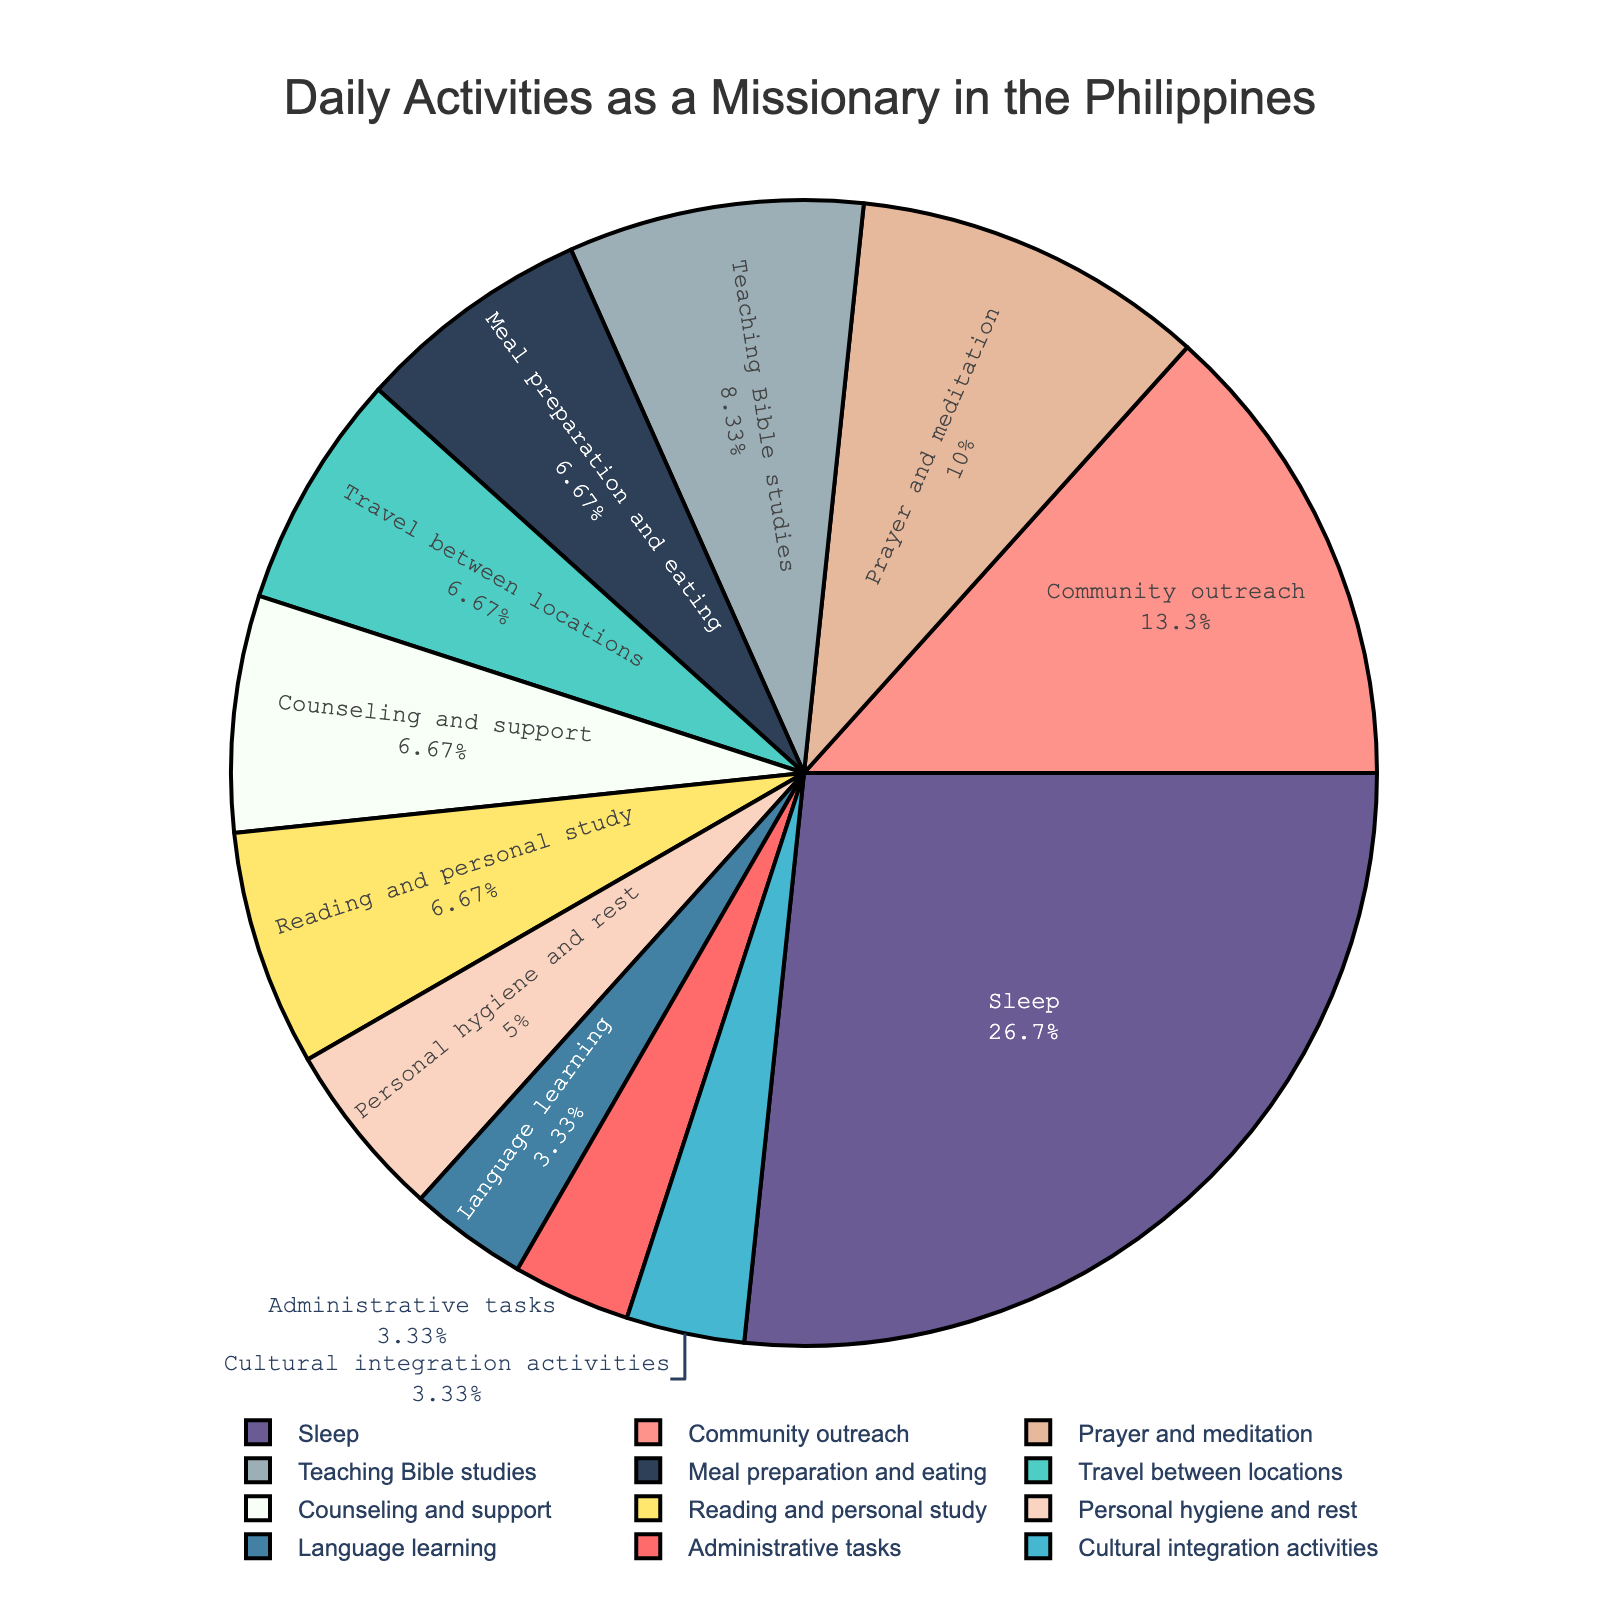What percentage of the day is spent on sleep? From the pie chart, locate the section labeled "Sleep" and read its corresponding percentage.
Answer: 33.3% How much more time is spent on community outreach than on meal preparation and eating? Identify the values for "Community outreach" (4 hours) and "Meal preparation and eating" (2 hours) from the pie chart. Then calculate the difference: 4 - 2.
Answer: 2 hours Which activity takes up the smallest portion of the day? By examining the pie chart, look for the smallest section, which is labeled "Administrative tasks" (1 hour).
Answer: Administrative tasks What's the total time spent on activities other than sleep? First, calculate the total hours displayed on the pie chart: sum all hours which gives 30. Then, subtract the hours spent on sleep (8): 30 - 8.
Answer: 22 hours How does the time spent on language learning compare to the time spent on teaching Bible studies? Find and compare the sections labeled "Language learning" (1 hour) and "Teaching Bible studies" (2.5 hours). Notice that the time spent on teaching Bible studies is greater.
Answer: Teaching Bible studies is 1.5 hours more What is the combined percentage of the day spent on prayer and meditation, and community outreach? Locate the percentages for "Prayer and meditation" and "Community outreach" from the pie chart, which are 10% and 13.3% respectively. Add these percentages together: 10 + 13.3.
Answer: 23.3% Compare the time spent on cultural integration activities to the time spent on counseling and support. From the pie chart, note the hours for "Cultural integration activities" (1 hour) and "Counseling and support" (2 hours). Calculate the difference: 2 - 1.
Answer: Counseling and support is 1 hour more How many hours in total are spent on reading and personal study combined with personal hygiene and rest? Find the hours for "Reading and personal study" (2 hours) and "Personal hygiene and rest" (1.5 hours) from the chart. Add them together: 2 + 1.5.
Answer: 3.5 hours What is the average time spent on meal preparation and eating, personal hygiene and rest, and administrative tasks? Find the hours for the given activities: "Meal preparation and eating" (2), "Personal hygiene and rest" (1.5), and "Administrative tasks" (1). Sum these hours: 2 + 1.5 + 1 = 4.5. Then divide by the number of activities: 4.5 ÷ 3.
Answer: 1.5 hours How does time allocated for travel between locations compare to the total time spent on community outreach and counseling and support? From the pie chart, get the time for "Travel between locations" (2 hours), "Community outreach" (4 hours), and "Counseling and support" (2 hours). Sum the latter two: 4 + 2 = 6, and then compare: 2 vs. 6.
Answer: Travel between locations is 4 hours less 